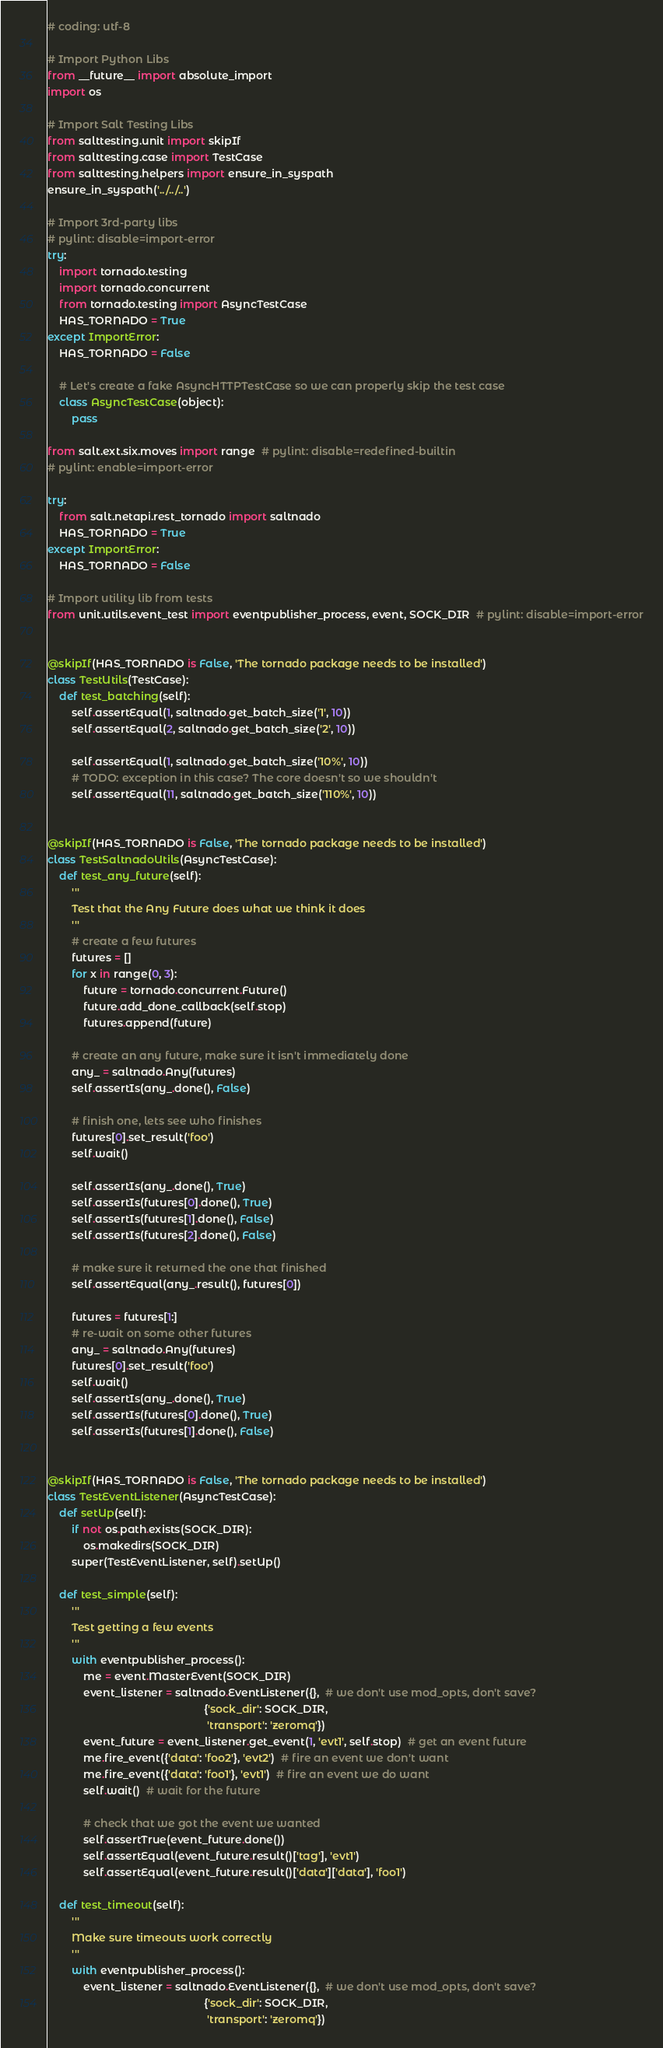<code> <loc_0><loc_0><loc_500><loc_500><_Python_># coding: utf-8

# Import Python Libs
from __future__ import absolute_import
import os

# Import Salt Testing Libs
from salttesting.unit import skipIf
from salttesting.case import TestCase
from salttesting.helpers import ensure_in_syspath
ensure_in_syspath('../../..')

# Import 3rd-party libs
# pylint: disable=import-error
try:
    import tornado.testing
    import tornado.concurrent
    from tornado.testing import AsyncTestCase
    HAS_TORNADO = True
except ImportError:
    HAS_TORNADO = False

    # Let's create a fake AsyncHTTPTestCase so we can properly skip the test case
    class AsyncTestCase(object):
        pass

from salt.ext.six.moves import range  # pylint: disable=redefined-builtin
# pylint: enable=import-error

try:
    from salt.netapi.rest_tornado import saltnado
    HAS_TORNADO = True
except ImportError:
    HAS_TORNADO = False

# Import utility lib from tests
from unit.utils.event_test import eventpublisher_process, event, SOCK_DIR  # pylint: disable=import-error


@skipIf(HAS_TORNADO is False, 'The tornado package needs to be installed')
class TestUtils(TestCase):
    def test_batching(self):
        self.assertEqual(1, saltnado.get_batch_size('1', 10))
        self.assertEqual(2, saltnado.get_batch_size('2', 10))

        self.assertEqual(1, saltnado.get_batch_size('10%', 10))
        # TODO: exception in this case? The core doesn't so we shouldn't
        self.assertEqual(11, saltnado.get_batch_size('110%', 10))


@skipIf(HAS_TORNADO is False, 'The tornado package needs to be installed')
class TestSaltnadoUtils(AsyncTestCase):
    def test_any_future(self):
        '''
        Test that the Any Future does what we think it does
        '''
        # create a few futures
        futures = []
        for x in range(0, 3):
            future = tornado.concurrent.Future()
            future.add_done_callback(self.stop)
            futures.append(future)

        # create an any future, make sure it isn't immediately done
        any_ = saltnado.Any(futures)
        self.assertIs(any_.done(), False)

        # finish one, lets see who finishes
        futures[0].set_result('foo')
        self.wait()

        self.assertIs(any_.done(), True)
        self.assertIs(futures[0].done(), True)
        self.assertIs(futures[1].done(), False)
        self.assertIs(futures[2].done(), False)

        # make sure it returned the one that finished
        self.assertEqual(any_.result(), futures[0])

        futures = futures[1:]
        # re-wait on some other futures
        any_ = saltnado.Any(futures)
        futures[0].set_result('foo')
        self.wait()
        self.assertIs(any_.done(), True)
        self.assertIs(futures[0].done(), True)
        self.assertIs(futures[1].done(), False)


@skipIf(HAS_TORNADO is False, 'The tornado package needs to be installed')
class TestEventListener(AsyncTestCase):
    def setUp(self):
        if not os.path.exists(SOCK_DIR):
            os.makedirs(SOCK_DIR)
        super(TestEventListener, self).setUp()

    def test_simple(self):
        '''
        Test getting a few events
        '''
        with eventpublisher_process():
            me = event.MasterEvent(SOCK_DIR)
            event_listener = saltnado.EventListener({},  # we don't use mod_opts, don't save?
                                                    {'sock_dir': SOCK_DIR,
                                                     'transport': 'zeromq'})
            event_future = event_listener.get_event(1, 'evt1', self.stop)  # get an event future
            me.fire_event({'data': 'foo2'}, 'evt2')  # fire an event we don't want
            me.fire_event({'data': 'foo1'}, 'evt1')  # fire an event we do want
            self.wait()  # wait for the future

            # check that we got the event we wanted
            self.assertTrue(event_future.done())
            self.assertEqual(event_future.result()['tag'], 'evt1')
            self.assertEqual(event_future.result()['data']['data'], 'foo1')

    def test_timeout(self):
        '''
        Make sure timeouts work correctly
        '''
        with eventpublisher_process():
            event_listener = saltnado.EventListener({},  # we don't use mod_opts, don't save?
                                                    {'sock_dir': SOCK_DIR,
                                                     'transport': 'zeromq'})</code> 